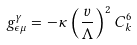Convert formula to latex. <formula><loc_0><loc_0><loc_500><loc_500>g ^ { \gamma } _ { \epsilon \mu } = - \kappa \left ( \frac { v } { \Lambda } \right ) ^ { 2 } C ^ { 6 } _ { k }</formula> 